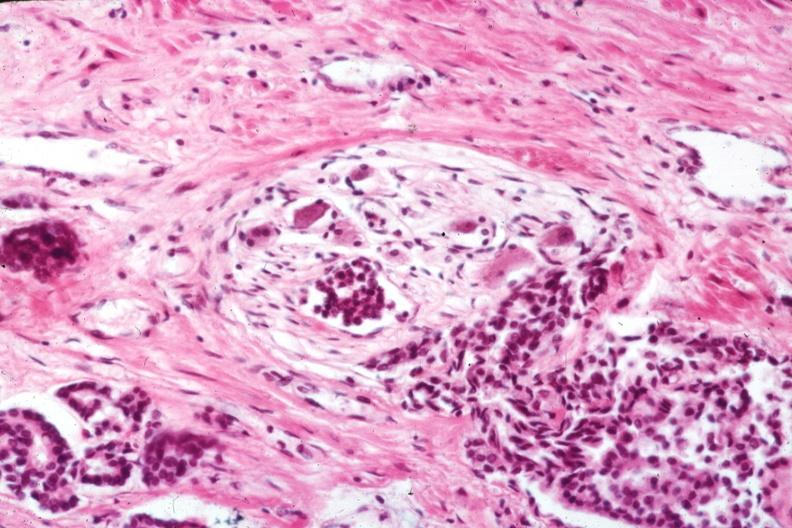what does this image show?
Answer the question using a single word or phrase. Excellent view of perineural invasion typical for lesion 